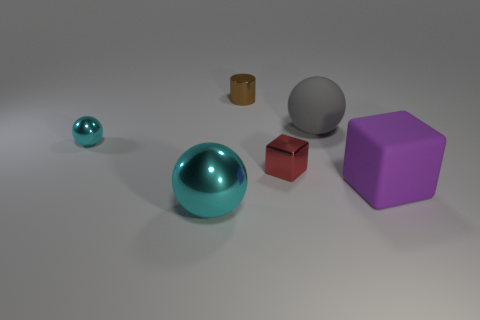What number of balls are tiny cyan shiny objects or large cyan objects?
Offer a terse response. 2. Is the number of tiny metal things on the left side of the small red metal block the same as the number of purple rubber objects that are on the right side of the large cyan object?
Provide a short and direct response. No. There is a metallic ball that is behind the metallic thing in front of the tiny red cube; how many large rubber spheres are in front of it?
Make the answer very short. 0. Do the tiny metallic sphere and the large sphere that is left of the red thing have the same color?
Ensure brevity in your answer.  Yes. Is the number of balls that are behind the tiny ball greater than the number of large gray shiny things?
Offer a very short reply. Yes. How many objects are cyan metal spheres that are in front of the purple cube or big objects to the left of the small brown shiny cylinder?
Make the answer very short. 1. The red object that is made of the same material as the small brown object is what size?
Provide a short and direct response. Small. There is a tiny shiny thing to the left of the small shiny cylinder; is its shape the same as the brown object?
Provide a short and direct response. No. There is a metallic object that is the same color as the small ball; what is its size?
Offer a terse response. Large. What number of brown objects are either large shiny spheres or rubber spheres?
Make the answer very short. 0. 